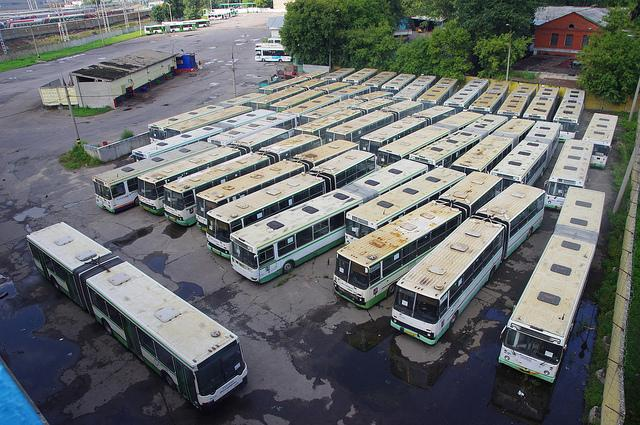What phrase best describes this place?

Choices:
A) bus depot
B) circus
C) football stadium
D) zoo bus depot 